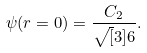Convert formula to latex. <formula><loc_0><loc_0><loc_500><loc_500>\psi ( r = 0 ) = \frac { C _ { 2 } } { \sqrt { [ } 3 ] { 6 } } .</formula> 